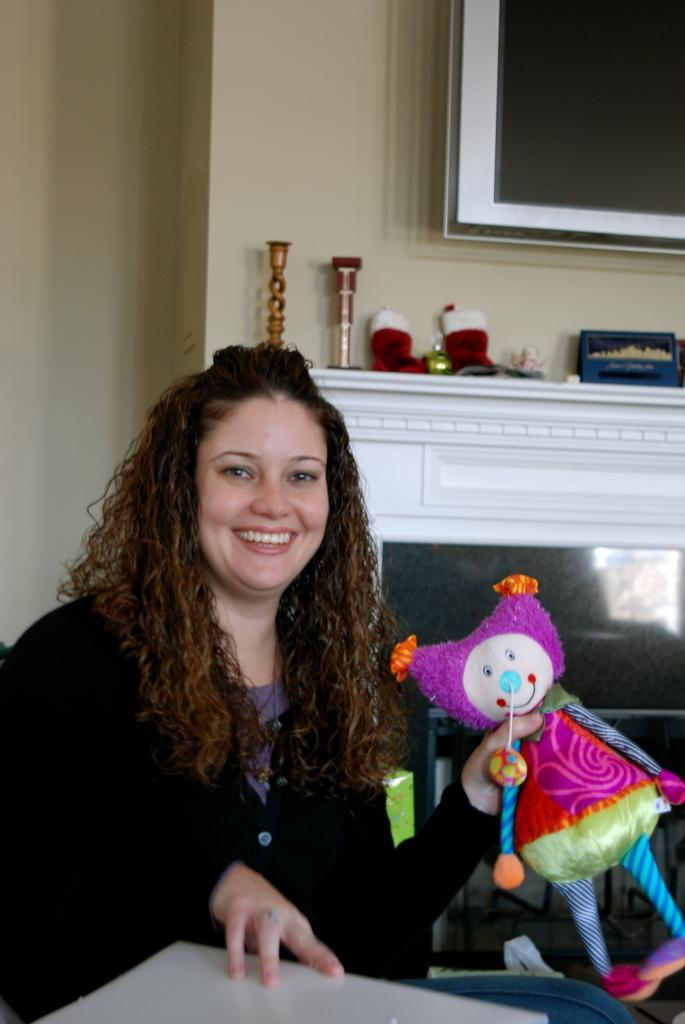What is the woman in the image doing? The woman is sitting in the image. What is the woman holding in the image? The woman is holding a doll. What can be seen in the background of the image? There is a wall in the background of the image. How many balloons are floating above the woman's head in the image? There are no balloons visible in the image. What type of tin can be seen on the wall in the image? There is no tin present on the wall in the image. 